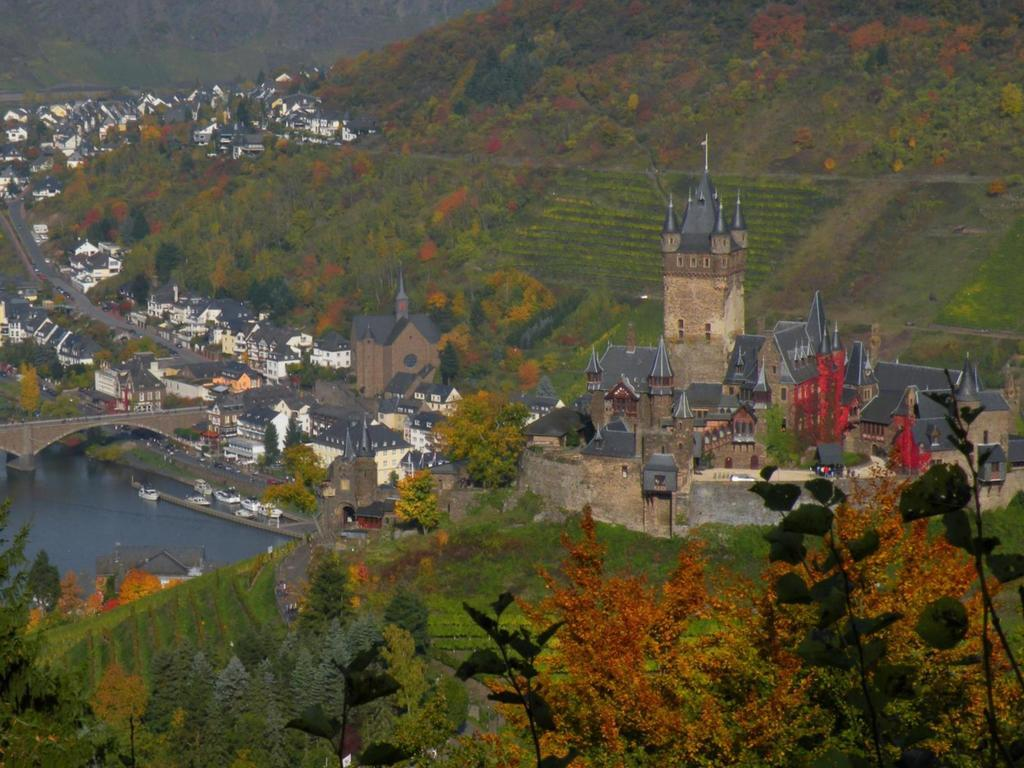What type of scene is depicted in the image? The image shows an outer view of a city. Can you describe any natural features visible in the image? Yes, there is a hill visible in the image. What type of man-made structures can be seen in the image? There are buildings, a tower, a bridge, and a lake in the image. Are there any plants or vegetation visible in the image? Yes, there are trees in the image. What language is spoken by the people in the image? There are no people visible in the image, so it is impossible to determine the language spoken. What type of soap is used to clean the bridge in the image? There is no soap or cleaning activity depicted in the image; the bridge is simply a part of the cityscape. 